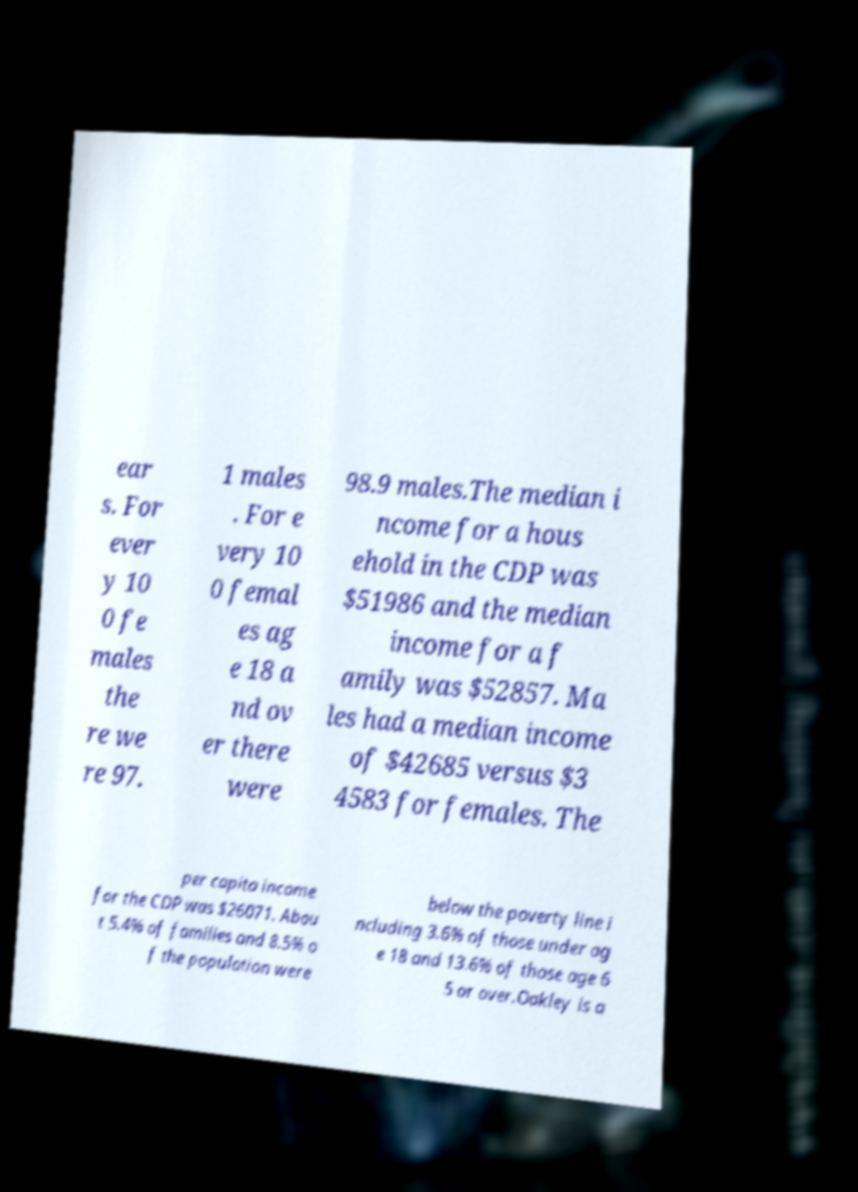Please identify and transcribe the text found in this image. ear s. For ever y 10 0 fe males the re we re 97. 1 males . For e very 10 0 femal es ag e 18 a nd ov er there were 98.9 males.The median i ncome for a hous ehold in the CDP was $51986 and the median income for a f amily was $52857. Ma les had a median income of $42685 versus $3 4583 for females. The per capita income for the CDP was $26071. Abou t 5.4% of families and 8.5% o f the population were below the poverty line i ncluding 3.6% of those under ag e 18 and 13.6% of those age 6 5 or over.Oakley is a 